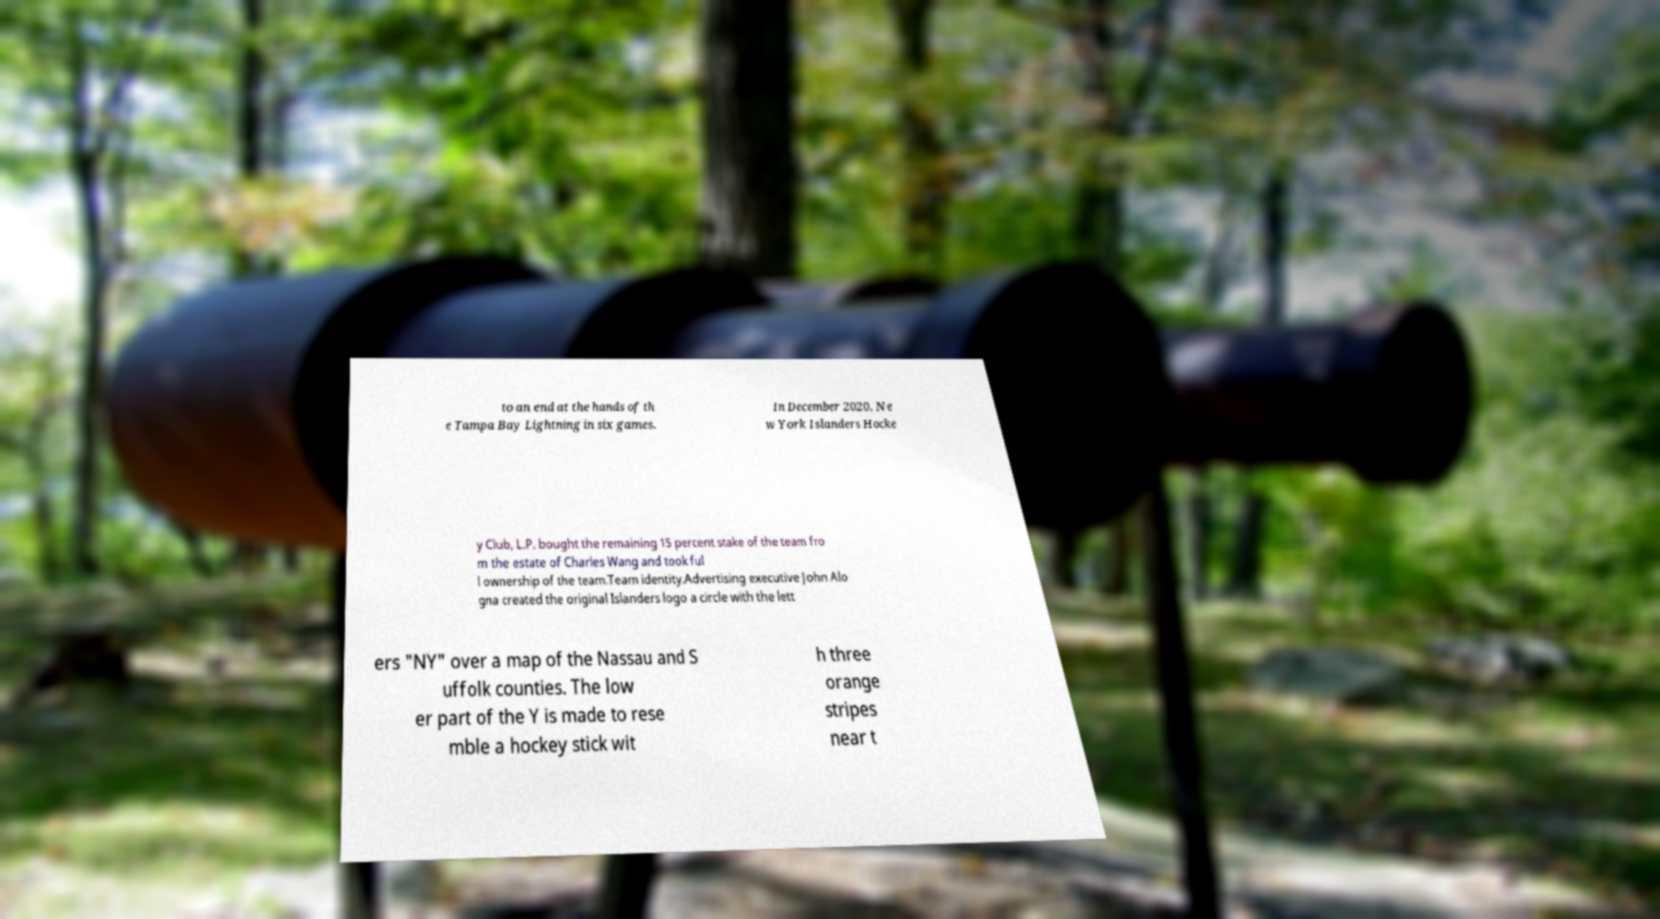There's text embedded in this image that I need extracted. Can you transcribe it verbatim? to an end at the hands of th e Tampa Bay Lightning in six games. In December 2020, Ne w York Islanders Hocke y Club, L.P. bought the remaining 15 percent stake of the team fro m the estate of Charles Wang and took ful l ownership of the team.Team identity.Advertising executive John Alo gna created the original Islanders logo a circle with the lett ers "NY" over a map of the Nassau and S uffolk counties. The low er part of the Y is made to rese mble a hockey stick wit h three orange stripes near t 